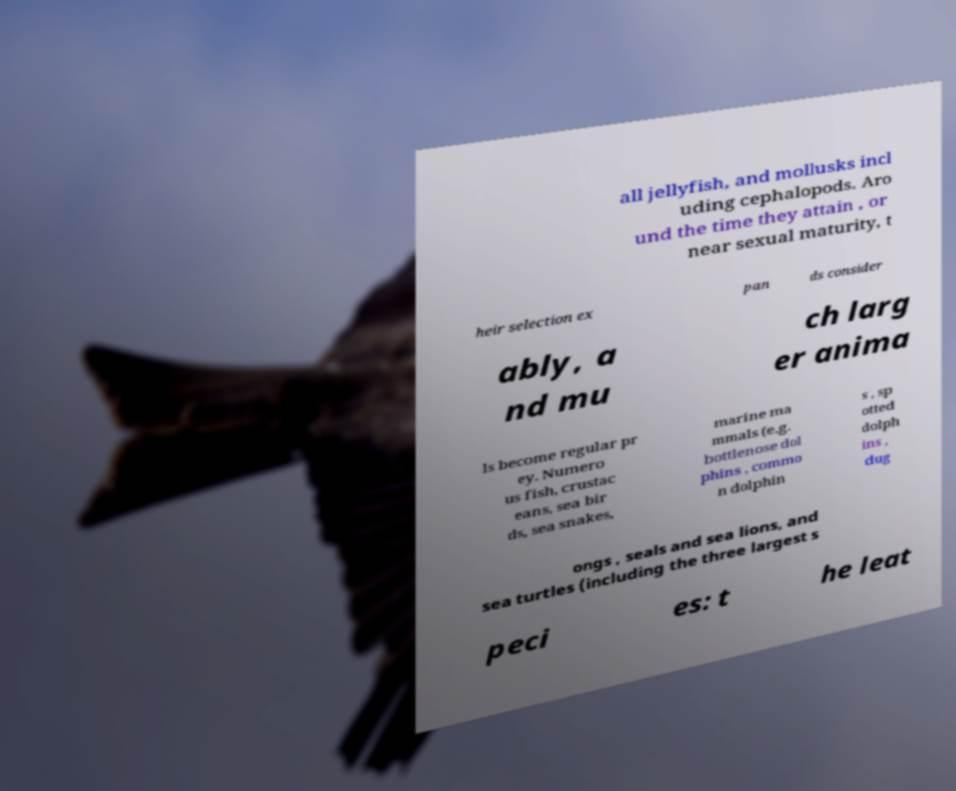Could you assist in decoding the text presented in this image and type it out clearly? all jellyfish, and mollusks incl uding cephalopods. Aro und the time they attain , or near sexual maturity, t heir selection ex pan ds consider ably, a nd mu ch larg er anima ls become regular pr ey. Numero us fish, crustac eans, sea bir ds, sea snakes, marine ma mmals (e.g. bottlenose dol phins , commo n dolphin s , sp otted dolph ins , dug ongs , seals and sea lions, and sea turtles (including the three largest s peci es: t he leat 